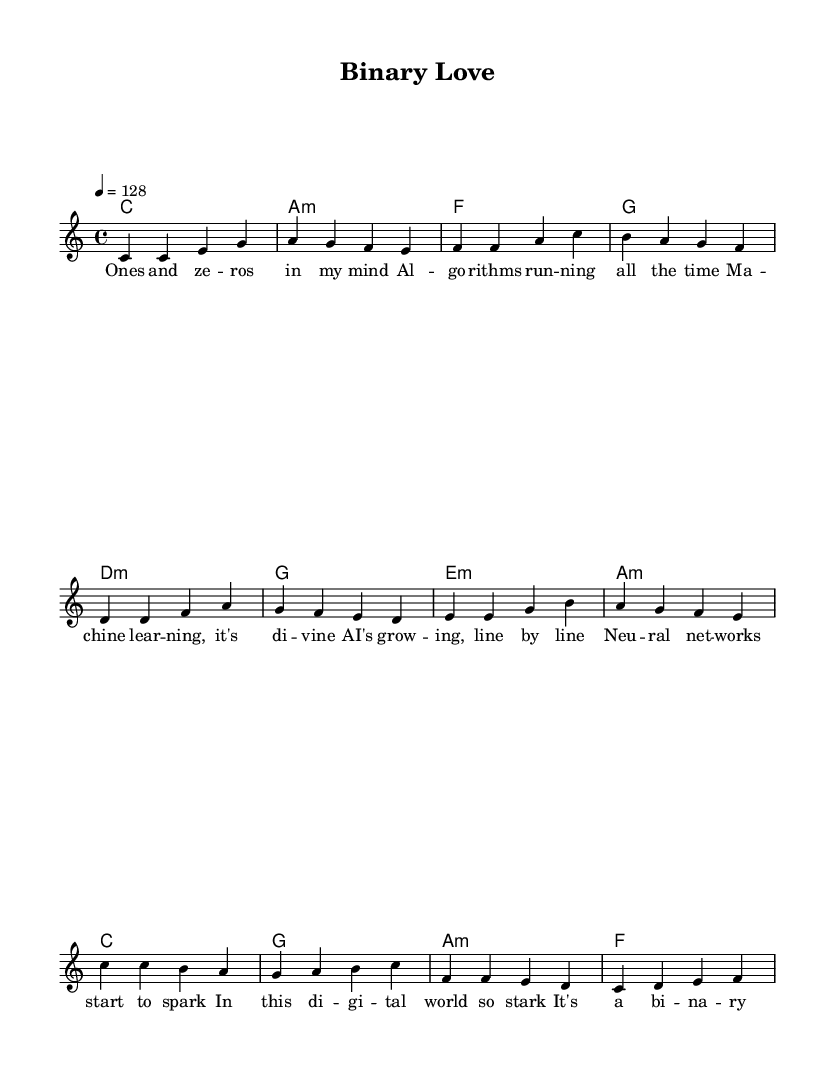What is the key signature of this music? The key signature indicated in the global section of the code is "c" which stands for C major, meaning there are no sharps or flats.
Answer: C major What is the time signature of this music? The time signature specified in the global section is "4/4", which means there are four beats in each measure and the quarter note receives one beat.
Answer: 4/4 What is the tempo marking of this piece? The tempo is indicated as "4 = 128", which means that the quarter note is to be played at a speed of 128 beats per minute.
Answer: 128 What is the primary theme of the lyrics? The primary theme involves artificial intelligence and machine learning, as emphasized in the words and phrases referring to algorithms and neural networks.
Answer: Artificial intelligence Which chord appears most frequently in the chorus? The chorus shows the chord sequence where "c1" appears initially, but the chord "g" appears right after "c" and is utilized in several pop songs. However, "a:m" appears twice and emphasizes the conflict between binary and emotional elements.
Answer: a:m What is the structure type of this pop song? The structure includes a verse, pre-chorus, and chorus, which is typical for pop songs designed to create an emotional buildup and resolution.
Answer: Verse, pre-chorus, chorus 